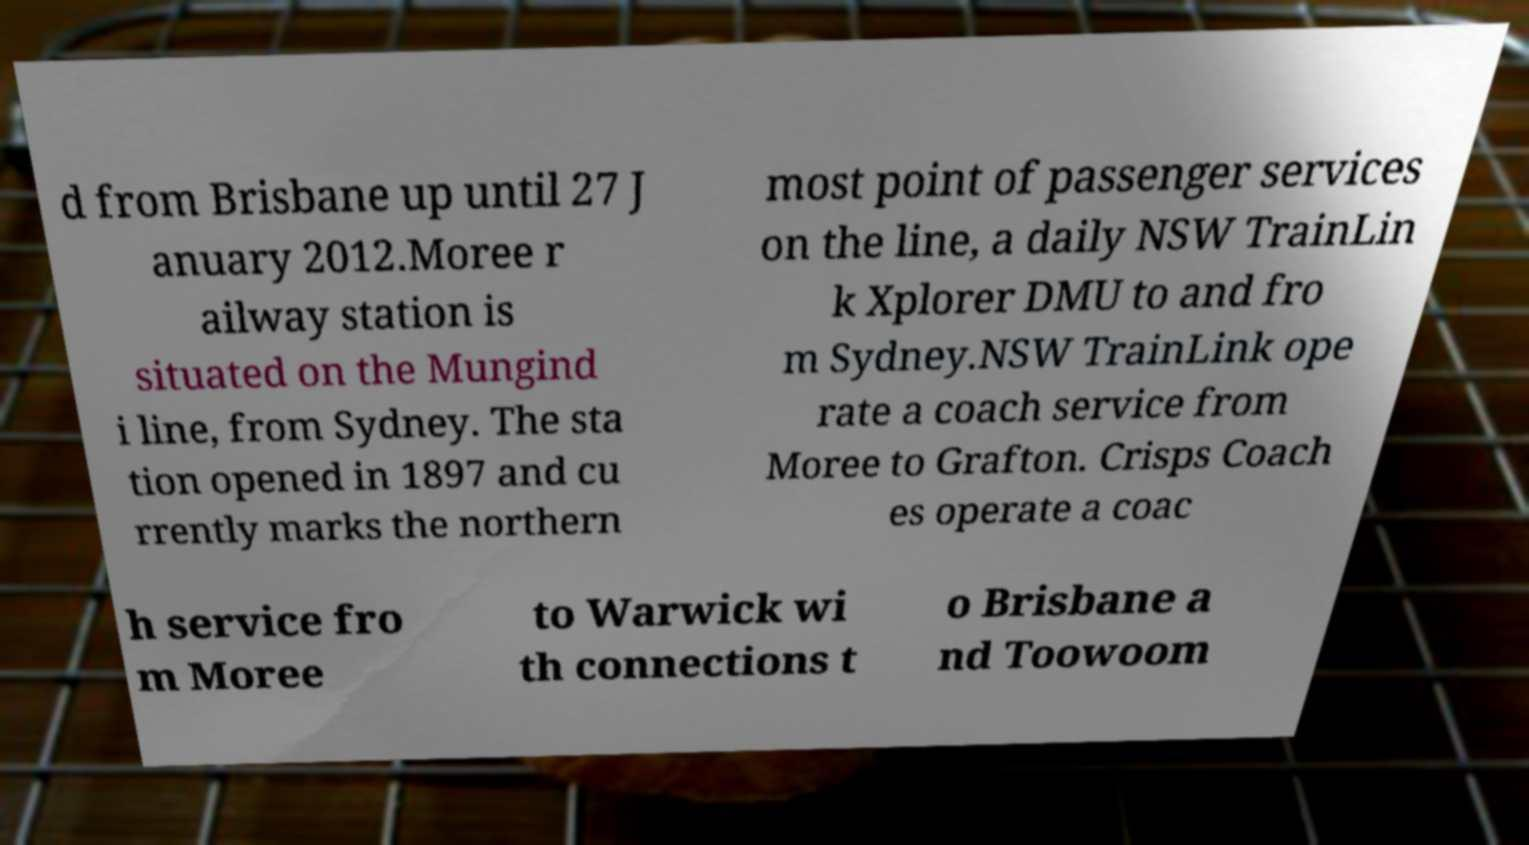Could you extract and type out the text from this image? d from Brisbane up until 27 J anuary 2012.Moree r ailway station is situated on the Mungind i line, from Sydney. The sta tion opened in 1897 and cu rrently marks the northern most point of passenger services on the line, a daily NSW TrainLin k Xplorer DMU to and fro m Sydney.NSW TrainLink ope rate a coach service from Moree to Grafton. Crisps Coach es operate a coac h service fro m Moree to Warwick wi th connections t o Brisbane a nd Toowoom 